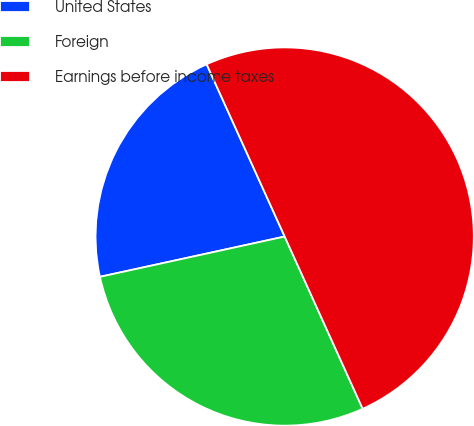<chart> <loc_0><loc_0><loc_500><loc_500><pie_chart><fcel>United States<fcel>Foreign<fcel>Earnings before income taxes<nl><fcel>21.65%<fcel>28.35%<fcel>50.0%<nl></chart> 